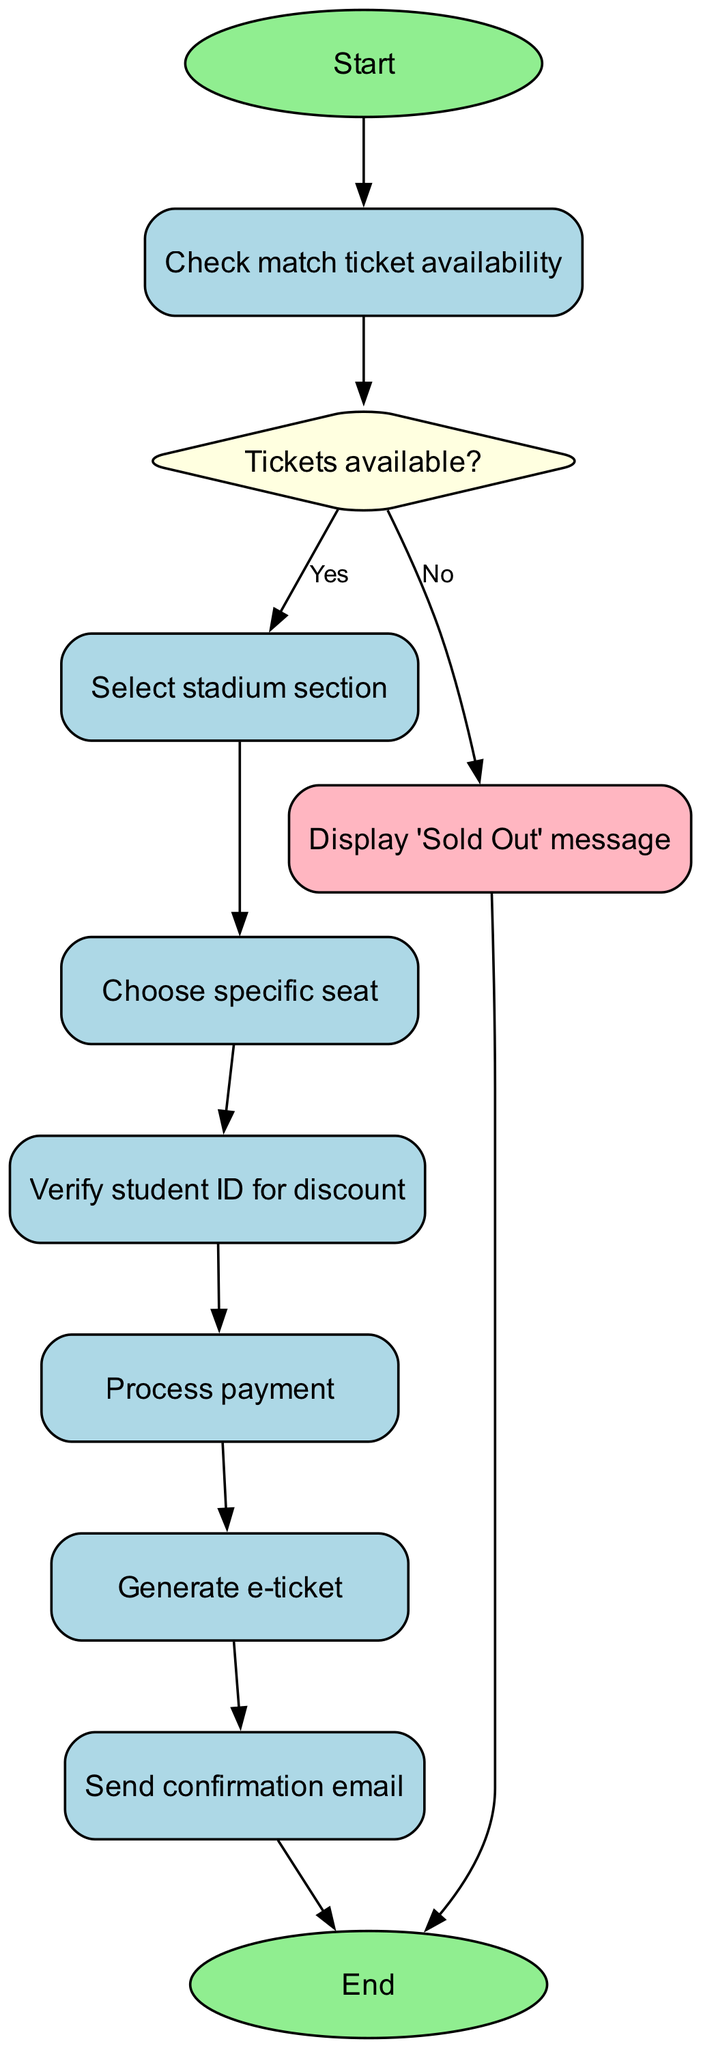What is the first step in the ticketing process? The diagram starts with the "Start" node, indicating that this is the entry point of the flowchart. The first action taken in the ticketing process is labeled "Check match ticket availability."
Answer: Check match ticket availability How many nodes are there in the diagram? By counting all the individual elements listed in the data, including start and end points, there are 10 nodes in total, representing different stages of the ticketing process.
Answer: 10 What happens if tickets are not available? The decision node "Tickets available?" has a branch labeled "No," which connects to "Display 'Sold Out' message." This indicates that if tickets are not available, a sold-out message will be shown.
Answer: Display 'Sold Out' message What is the last step before the process ends? The final step listed just before the "End" node is "Send confirmation email." This indicates that after generating the ticket, a confirmation email is sent to the customer.
Answer: Send confirmation email How many decision points are in the flowchart? The flowchart contains two decision points: the check for ticket availability ("Tickets available?") and the verification of student ID for discounts.
Answer: 2 What node follows the selection of the stadium section? After "Select stadium section," the next node in the process is "Choose specific seat." This indicates that the user must select a seat following the selection of the section.
Answer: Choose specific seat What is required to qualify for a discount? The flowchart includes a node labeled "Verify student ID for discount," meaning that the user must verify their student ID to qualify for a discounted ticket.
Answer: Verify student ID Are there any nodes that indicate an end to the process? Yes, the flowchart has two nodes that lead to the end: the "End" node from both "Send confirmation email" and "Display 'Sold Out' message." Both paths eventually lead to the termination of the process.
Answer: End What is the purpose of the "Process payment" step? The "Process payment" step is essential to complete the transaction of acquiring the match tickets after selecting seats and verifying discounts, thus ensuring that the payment is successfully handled before issuing the ticket.
Answer: Complete the transaction 